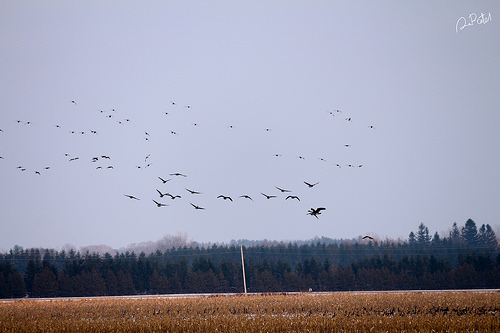<image>
Is the bird above the ground? Yes. The bird is positioned above the ground in the vertical space, higher up in the scene. 